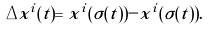<formula> <loc_0><loc_0><loc_500><loc_500>\Delta x ^ { i } ( t ) = x ^ { i } ( \sigma ( t ) ) - x ^ { i } ( \tilde { \sigma } ( t ) ) .</formula> 